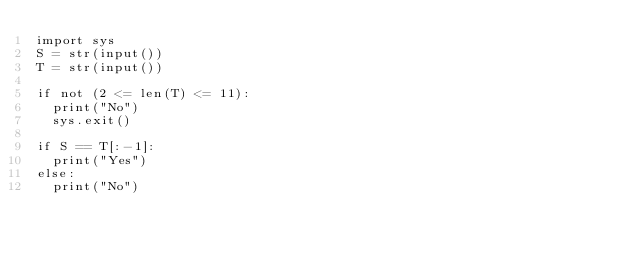Convert code to text. <code><loc_0><loc_0><loc_500><loc_500><_Python_>import sys
S = str(input())
T = str(input())

if not (2 <= len(T) <= 11):
	print("No")
	sys.exit()

if S == T[:-1]:
	print("Yes")
else:
	print("No")</code> 